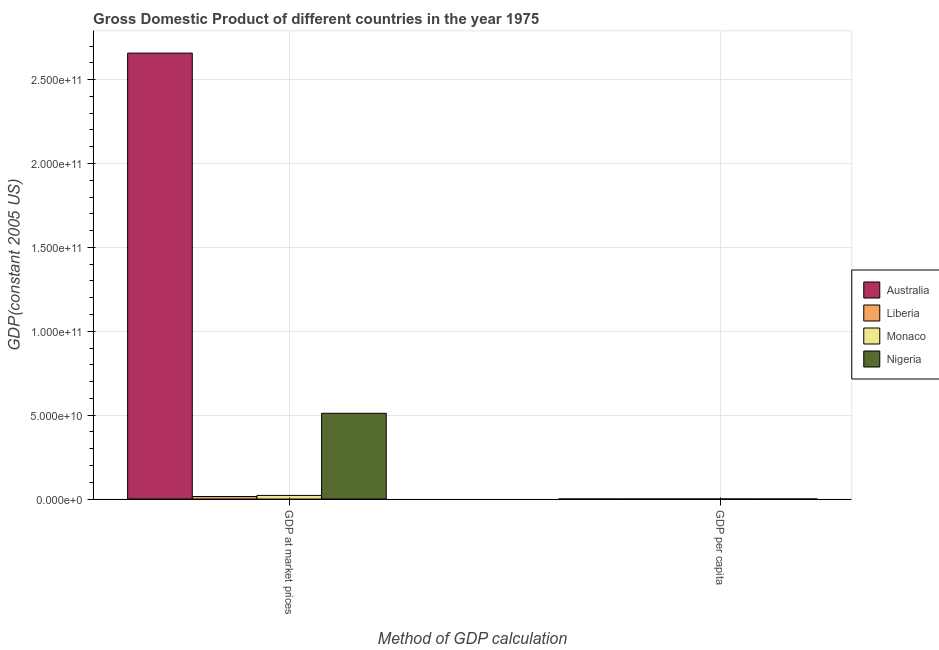What is the label of the 1st group of bars from the left?
Make the answer very short. GDP at market prices. What is the gdp per capita in Australia?
Ensure brevity in your answer.  1.91e+04. Across all countries, what is the maximum gdp at market prices?
Offer a very short reply. 2.66e+11. Across all countries, what is the minimum gdp per capita?
Provide a succinct answer. 804.05. In which country was the gdp at market prices maximum?
Ensure brevity in your answer.  Australia. In which country was the gdp per capita minimum?
Your answer should be very brief. Nigeria. What is the total gdp at market prices in the graph?
Give a very brief answer. 3.21e+11. What is the difference between the gdp per capita in Nigeria and that in Australia?
Provide a succinct answer. -1.83e+04. What is the difference between the gdp at market prices in Monaco and the gdp per capita in Australia?
Keep it short and to the point. 2.15e+09. What is the average gdp at market prices per country?
Keep it short and to the point. 8.01e+1. What is the difference between the gdp at market prices and gdp per capita in Nigeria?
Provide a short and direct response. 5.11e+1. What is the ratio of the gdp at market prices in Liberia to that in Nigeria?
Make the answer very short. 0.03. What does the 3rd bar from the left in GDP per capita represents?
Give a very brief answer. Monaco. What does the 4th bar from the right in GDP per capita represents?
Offer a very short reply. Australia. How many bars are there?
Keep it short and to the point. 8. How many countries are there in the graph?
Keep it short and to the point. 4. Are the values on the major ticks of Y-axis written in scientific E-notation?
Provide a short and direct response. Yes. How many legend labels are there?
Offer a very short reply. 4. What is the title of the graph?
Ensure brevity in your answer.  Gross Domestic Product of different countries in the year 1975. What is the label or title of the X-axis?
Keep it short and to the point. Method of GDP calculation. What is the label or title of the Y-axis?
Your answer should be compact. GDP(constant 2005 US). What is the GDP(constant 2005 US) in Australia in GDP at market prices?
Give a very brief answer. 2.66e+11. What is the GDP(constant 2005 US) in Liberia in GDP at market prices?
Offer a very short reply. 1.50e+09. What is the GDP(constant 2005 US) of Monaco in GDP at market prices?
Your response must be concise. 2.15e+09. What is the GDP(constant 2005 US) in Nigeria in GDP at market prices?
Keep it short and to the point. 5.11e+1. What is the GDP(constant 2005 US) of Australia in GDP per capita?
Provide a succinct answer. 1.91e+04. What is the GDP(constant 2005 US) of Liberia in GDP per capita?
Provide a short and direct response. 919.5. What is the GDP(constant 2005 US) of Monaco in GDP per capita?
Your answer should be compact. 8.54e+04. What is the GDP(constant 2005 US) in Nigeria in GDP per capita?
Ensure brevity in your answer.  804.05. Across all Method of GDP calculation, what is the maximum GDP(constant 2005 US) in Australia?
Provide a succinct answer. 2.66e+11. Across all Method of GDP calculation, what is the maximum GDP(constant 2005 US) of Liberia?
Give a very brief answer. 1.50e+09. Across all Method of GDP calculation, what is the maximum GDP(constant 2005 US) in Monaco?
Your answer should be compact. 2.15e+09. Across all Method of GDP calculation, what is the maximum GDP(constant 2005 US) of Nigeria?
Offer a terse response. 5.11e+1. Across all Method of GDP calculation, what is the minimum GDP(constant 2005 US) in Australia?
Your answer should be very brief. 1.91e+04. Across all Method of GDP calculation, what is the minimum GDP(constant 2005 US) in Liberia?
Keep it short and to the point. 919.5. Across all Method of GDP calculation, what is the minimum GDP(constant 2005 US) of Monaco?
Your answer should be compact. 8.54e+04. Across all Method of GDP calculation, what is the minimum GDP(constant 2005 US) of Nigeria?
Ensure brevity in your answer.  804.05. What is the total GDP(constant 2005 US) of Australia in the graph?
Your response must be concise. 2.66e+11. What is the total GDP(constant 2005 US) in Liberia in the graph?
Provide a succinct answer. 1.50e+09. What is the total GDP(constant 2005 US) in Monaco in the graph?
Give a very brief answer. 2.15e+09. What is the total GDP(constant 2005 US) in Nigeria in the graph?
Provide a short and direct response. 5.11e+1. What is the difference between the GDP(constant 2005 US) in Australia in GDP at market prices and that in GDP per capita?
Your answer should be compact. 2.66e+11. What is the difference between the GDP(constant 2005 US) in Liberia in GDP at market prices and that in GDP per capita?
Keep it short and to the point. 1.50e+09. What is the difference between the GDP(constant 2005 US) of Monaco in GDP at market prices and that in GDP per capita?
Give a very brief answer. 2.15e+09. What is the difference between the GDP(constant 2005 US) of Nigeria in GDP at market prices and that in GDP per capita?
Provide a succinct answer. 5.11e+1. What is the difference between the GDP(constant 2005 US) in Australia in GDP at market prices and the GDP(constant 2005 US) in Liberia in GDP per capita?
Your answer should be very brief. 2.66e+11. What is the difference between the GDP(constant 2005 US) in Australia in GDP at market prices and the GDP(constant 2005 US) in Monaco in GDP per capita?
Keep it short and to the point. 2.66e+11. What is the difference between the GDP(constant 2005 US) in Australia in GDP at market prices and the GDP(constant 2005 US) in Nigeria in GDP per capita?
Make the answer very short. 2.66e+11. What is the difference between the GDP(constant 2005 US) in Liberia in GDP at market prices and the GDP(constant 2005 US) in Monaco in GDP per capita?
Provide a succinct answer. 1.50e+09. What is the difference between the GDP(constant 2005 US) of Liberia in GDP at market prices and the GDP(constant 2005 US) of Nigeria in GDP per capita?
Keep it short and to the point. 1.50e+09. What is the difference between the GDP(constant 2005 US) in Monaco in GDP at market prices and the GDP(constant 2005 US) in Nigeria in GDP per capita?
Provide a succinct answer. 2.15e+09. What is the average GDP(constant 2005 US) in Australia per Method of GDP calculation?
Make the answer very short. 1.33e+11. What is the average GDP(constant 2005 US) of Liberia per Method of GDP calculation?
Give a very brief answer. 7.49e+08. What is the average GDP(constant 2005 US) in Monaco per Method of GDP calculation?
Keep it short and to the point. 1.08e+09. What is the average GDP(constant 2005 US) in Nigeria per Method of GDP calculation?
Provide a short and direct response. 2.56e+1. What is the difference between the GDP(constant 2005 US) of Australia and GDP(constant 2005 US) of Liberia in GDP at market prices?
Your answer should be compact. 2.64e+11. What is the difference between the GDP(constant 2005 US) of Australia and GDP(constant 2005 US) of Monaco in GDP at market prices?
Make the answer very short. 2.64e+11. What is the difference between the GDP(constant 2005 US) of Australia and GDP(constant 2005 US) of Nigeria in GDP at market prices?
Provide a succinct answer. 2.15e+11. What is the difference between the GDP(constant 2005 US) in Liberia and GDP(constant 2005 US) in Monaco in GDP at market prices?
Keep it short and to the point. -6.55e+08. What is the difference between the GDP(constant 2005 US) of Liberia and GDP(constant 2005 US) of Nigeria in GDP at market prices?
Provide a short and direct response. -4.96e+1. What is the difference between the GDP(constant 2005 US) of Monaco and GDP(constant 2005 US) of Nigeria in GDP at market prices?
Offer a terse response. -4.90e+1. What is the difference between the GDP(constant 2005 US) of Australia and GDP(constant 2005 US) of Liberia in GDP per capita?
Your answer should be compact. 1.82e+04. What is the difference between the GDP(constant 2005 US) of Australia and GDP(constant 2005 US) of Monaco in GDP per capita?
Offer a very short reply. -6.63e+04. What is the difference between the GDP(constant 2005 US) in Australia and GDP(constant 2005 US) in Nigeria in GDP per capita?
Provide a short and direct response. 1.83e+04. What is the difference between the GDP(constant 2005 US) of Liberia and GDP(constant 2005 US) of Monaco in GDP per capita?
Keep it short and to the point. -8.45e+04. What is the difference between the GDP(constant 2005 US) in Liberia and GDP(constant 2005 US) in Nigeria in GDP per capita?
Provide a short and direct response. 115.45. What is the difference between the GDP(constant 2005 US) of Monaco and GDP(constant 2005 US) of Nigeria in GDP per capita?
Your answer should be compact. 8.46e+04. What is the ratio of the GDP(constant 2005 US) in Australia in GDP at market prices to that in GDP per capita?
Keep it short and to the point. 1.39e+07. What is the ratio of the GDP(constant 2005 US) in Liberia in GDP at market prices to that in GDP per capita?
Provide a succinct answer. 1.63e+06. What is the ratio of the GDP(constant 2005 US) in Monaco in GDP at market prices to that in GDP per capita?
Offer a very short reply. 2.52e+04. What is the ratio of the GDP(constant 2005 US) of Nigeria in GDP at market prices to that in GDP per capita?
Your answer should be compact. 6.36e+07. What is the difference between the highest and the second highest GDP(constant 2005 US) of Australia?
Give a very brief answer. 2.66e+11. What is the difference between the highest and the second highest GDP(constant 2005 US) in Liberia?
Keep it short and to the point. 1.50e+09. What is the difference between the highest and the second highest GDP(constant 2005 US) in Monaco?
Ensure brevity in your answer.  2.15e+09. What is the difference between the highest and the second highest GDP(constant 2005 US) in Nigeria?
Ensure brevity in your answer.  5.11e+1. What is the difference between the highest and the lowest GDP(constant 2005 US) in Australia?
Keep it short and to the point. 2.66e+11. What is the difference between the highest and the lowest GDP(constant 2005 US) of Liberia?
Make the answer very short. 1.50e+09. What is the difference between the highest and the lowest GDP(constant 2005 US) of Monaco?
Provide a succinct answer. 2.15e+09. What is the difference between the highest and the lowest GDP(constant 2005 US) of Nigeria?
Your answer should be compact. 5.11e+1. 